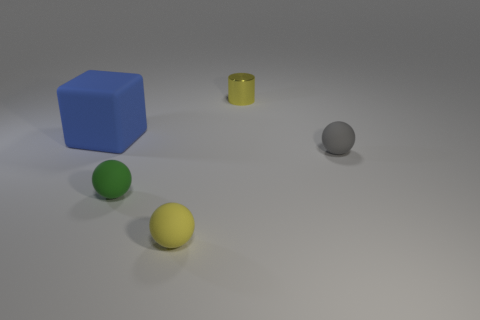Is there anything else that has the same material as the tiny cylinder?
Your answer should be compact. No. What material is the object that is the same color as the cylinder?
Ensure brevity in your answer.  Rubber. What is the color of the matte cube?
Your answer should be compact. Blue. Are there any yellow metallic things right of the small rubber sphere behind the tiny green object?
Your response must be concise. No. What is the material of the cube?
Provide a short and direct response. Rubber. Is the material of the object behind the big blue block the same as the small yellow object that is in front of the small gray matte object?
Keep it short and to the point. No. Is there anything else that is the same color as the matte cube?
Give a very brief answer. No. How big is the object that is behind the gray rubber object and right of the big matte cube?
Offer a terse response. Small. Is the shape of the tiny yellow object that is behind the tiny gray object the same as the yellow object in front of the blue matte block?
Your response must be concise. No. There is a object that is the same color as the tiny metal cylinder; what shape is it?
Make the answer very short. Sphere. 